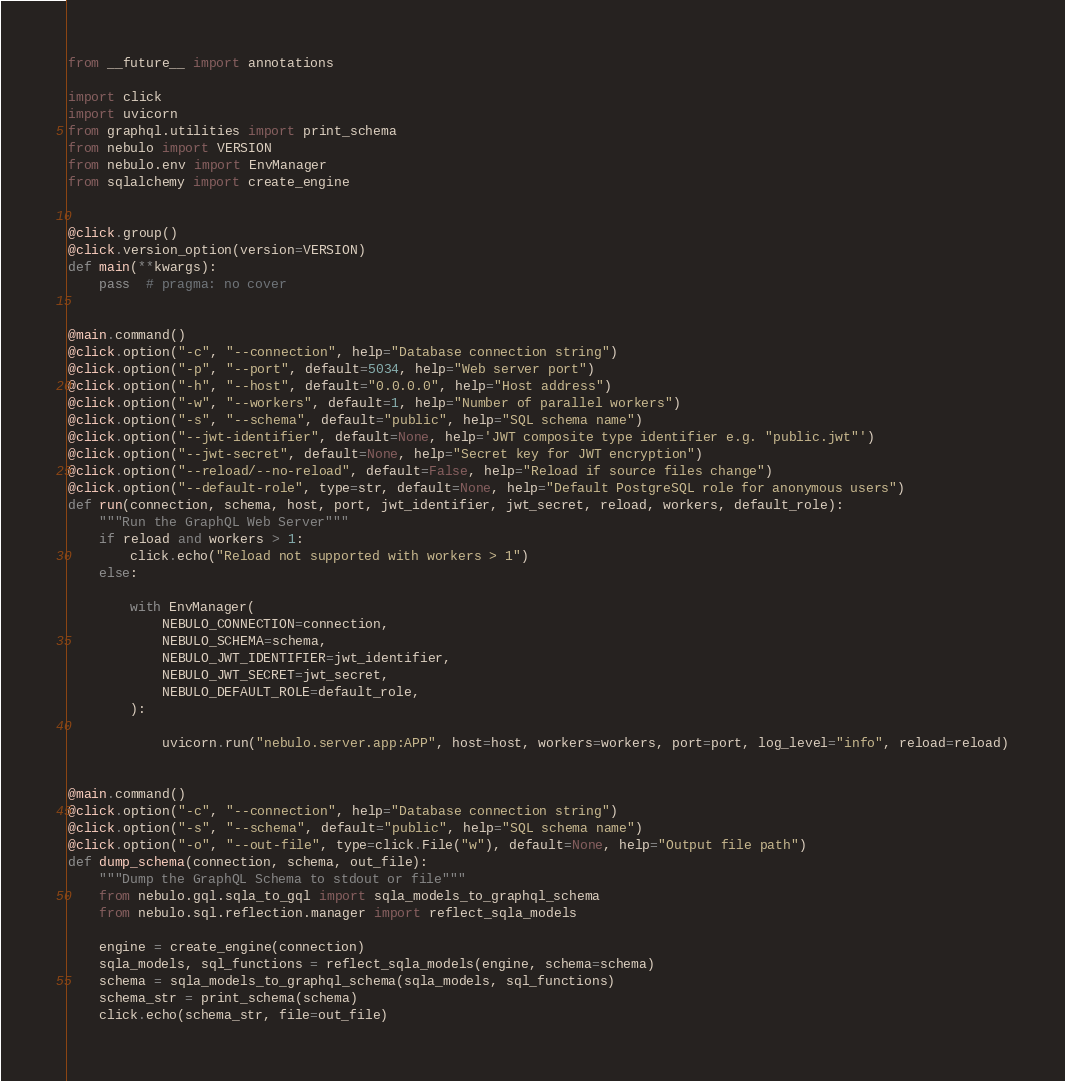Convert code to text. <code><loc_0><loc_0><loc_500><loc_500><_Python_>from __future__ import annotations

import click
import uvicorn
from graphql.utilities import print_schema
from nebulo import VERSION
from nebulo.env import EnvManager
from sqlalchemy import create_engine


@click.group()
@click.version_option(version=VERSION)
def main(**kwargs):
    pass  # pragma: no cover


@main.command()
@click.option("-c", "--connection", help="Database connection string")
@click.option("-p", "--port", default=5034, help="Web server port")
@click.option("-h", "--host", default="0.0.0.0", help="Host address")
@click.option("-w", "--workers", default=1, help="Number of parallel workers")
@click.option("-s", "--schema", default="public", help="SQL schema name")
@click.option("--jwt-identifier", default=None, help='JWT composite type identifier e.g. "public.jwt"')
@click.option("--jwt-secret", default=None, help="Secret key for JWT encryption")
@click.option("--reload/--no-reload", default=False, help="Reload if source files change")
@click.option("--default-role", type=str, default=None, help="Default PostgreSQL role for anonymous users")
def run(connection, schema, host, port, jwt_identifier, jwt_secret, reload, workers, default_role):
    """Run the GraphQL Web Server"""
    if reload and workers > 1:
        click.echo("Reload not supported with workers > 1")
    else:

        with EnvManager(
            NEBULO_CONNECTION=connection,
            NEBULO_SCHEMA=schema,
            NEBULO_JWT_IDENTIFIER=jwt_identifier,
            NEBULO_JWT_SECRET=jwt_secret,
            NEBULO_DEFAULT_ROLE=default_role,
        ):

            uvicorn.run("nebulo.server.app:APP", host=host, workers=workers, port=port, log_level="info", reload=reload)


@main.command()
@click.option("-c", "--connection", help="Database connection string")
@click.option("-s", "--schema", default="public", help="SQL schema name")
@click.option("-o", "--out-file", type=click.File("w"), default=None, help="Output file path")
def dump_schema(connection, schema, out_file):
    """Dump the GraphQL Schema to stdout or file"""
    from nebulo.gql.sqla_to_gql import sqla_models_to_graphql_schema
    from nebulo.sql.reflection.manager import reflect_sqla_models

    engine = create_engine(connection)
    sqla_models, sql_functions = reflect_sqla_models(engine, schema=schema)
    schema = sqla_models_to_graphql_schema(sqla_models, sql_functions)
    schema_str = print_schema(schema)
    click.echo(schema_str, file=out_file)
</code> 